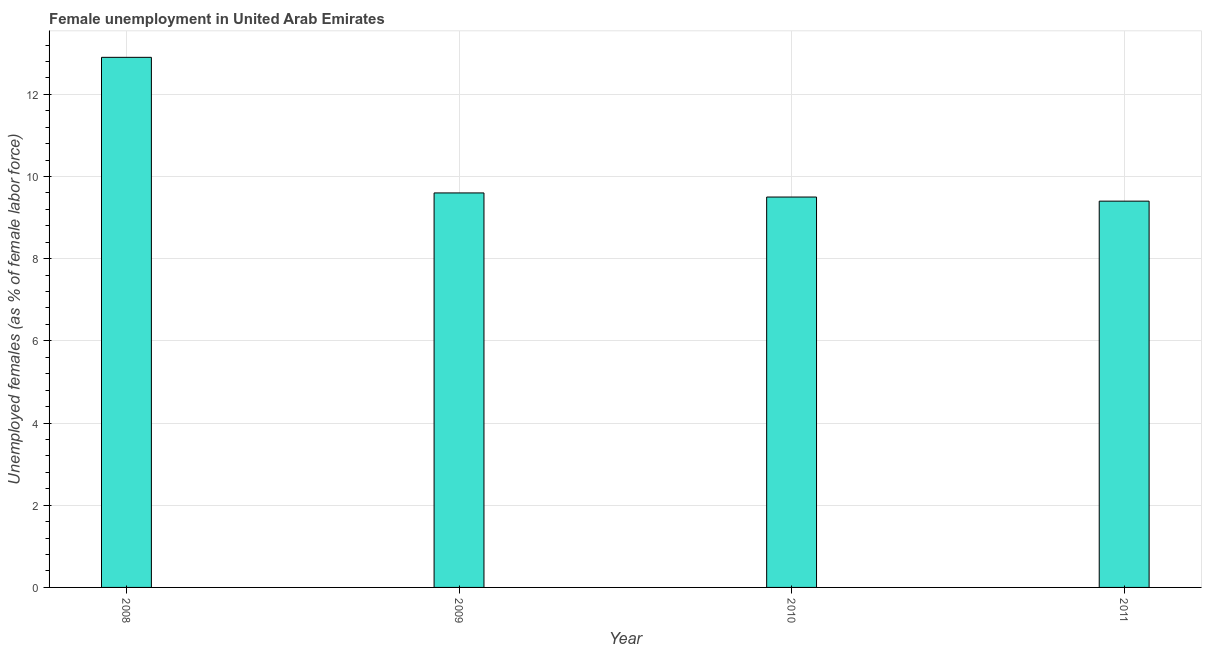Does the graph contain grids?
Your answer should be compact. Yes. What is the title of the graph?
Make the answer very short. Female unemployment in United Arab Emirates. What is the label or title of the Y-axis?
Provide a short and direct response. Unemployed females (as % of female labor force). What is the unemployed females population in 2011?
Your answer should be compact. 9.4. Across all years, what is the maximum unemployed females population?
Provide a succinct answer. 12.9. Across all years, what is the minimum unemployed females population?
Keep it short and to the point. 9.4. What is the sum of the unemployed females population?
Ensure brevity in your answer.  41.4. What is the difference between the unemployed females population in 2008 and 2009?
Keep it short and to the point. 3.3. What is the average unemployed females population per year?
Keep it short and to the point. 10.35. What is the median unemployed females population?
Your answer should be compact. 9.55. What is the ratio of the unemployed females population in 2010 to that in 2011?
Ensure brevity in your answer.  1.01. Is the unemployed females population in 2008 less than that in 2009?
Give a very brief answer. No. In how many years, is the unemployed females population greater than the average unemployed females population taken over all years?
Provide a succinct answer. 1. How many bars are there?
Your answer should be compact. 4. Are all the bars in the graph horizontal?
Offer a terse response. No. How many years are there in the graph?
Your answer should be compact. 4. What is the Unemployed females (as % of female labor force) of 2008?
Your answer should be very brief. 12.9. What is the Unemployed females (as % of female labor force) of 2009?
Ensure brevity in your answer.  9.6. What is the Unemployed females (as % of female labor force) in 2010?
Provide a succinct answer. 9.5. What is the Unemployed females (as % of female labor force) in 2011?
Keep it short and to the point. 9.4. What is the difference between the Unemployed females (as % of female labor force) in 2008 and 2009?
Make the answer very short. 3.3. What is the difference between the Unemployed females (as % of female labor force) in 2009 and 2010?
Make the answer very short. 0.1. What is the difference between the Unemployed females (as % of female labor force) in 2010 and 2011?
Your response must be concise. 0.1. What is the ratio of the Unemployed females (as % of female labor force) in 2008 to that in 2009?
Give a very brief answer. 1.34. What is the ratio of the Unemployed females (as % of female labor force) in 2008 to that in 2010?
Offer a terse response. 1.36. What is the ratio of the Unemployed females (as % of female labor force) in 2008 to that in 2011?
Offer a very short reply. 1.37. What is the ratio of the Unemployed females (as % of female labor force) in 2010 to that in 2011?
Your response must be concise. 1.01. 